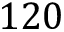Convert formula to latex. <formula><loc_0><loc_0><loc_500><loc_500>1 2 0</formula> 